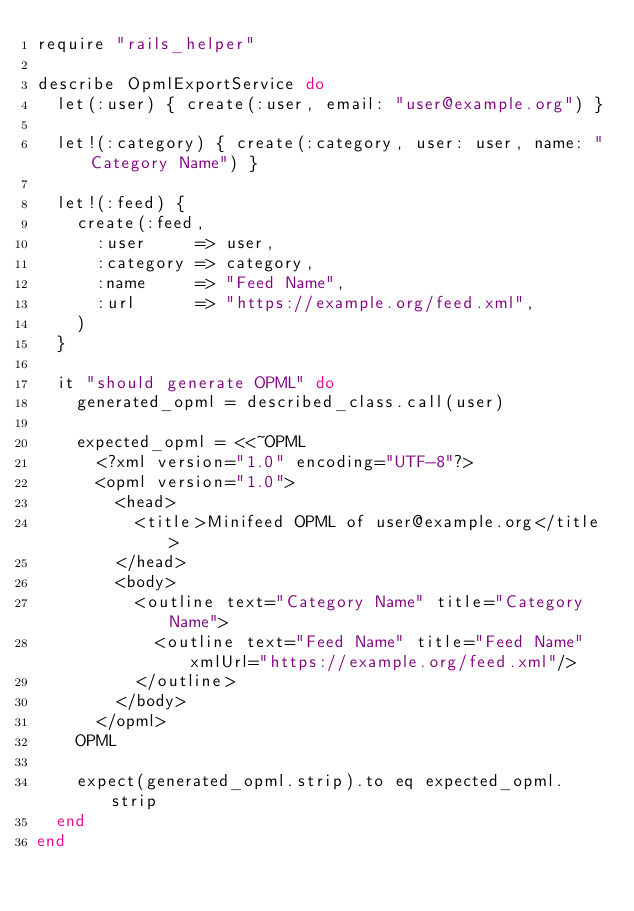<code> <loc_0><loc_0><loc_500><loc_500><_Ruby_>require "rails_helper"

describe OpmlExportService do
  let(:user) { create(:user, email: "user@example.org") }

  let!(:category) { create(:category, user: user, name: "Category Name") }

  let!(:feed) {
    create(:feed,
      :user     => user,
      :category => category,
      :name     => "Feed Name",
      :url      => "https://example.org/feed.xml",
    )
  }

  it "should generate OPML" do
    generated_opml = described_class.call(user)

    expected_opml = <<~OPML
      <?xml version="1.0" encoding="UTF-8"?>
      <opml version="1.0">
        <head>
          <title>Minifeed OPML of user@example.org</title>
        </head>
        <body>
          <outline text="Category Name" title="Category Name">
            <outline text="Feed Name" title="Feed Name" xmlUrl="https://example.org/feed.xml"/>
          </outline>
        </body>
      </opml>
    OPML

    expect(generated_opml.strip).to eq expected_opml.strip
  end
end
</code> 